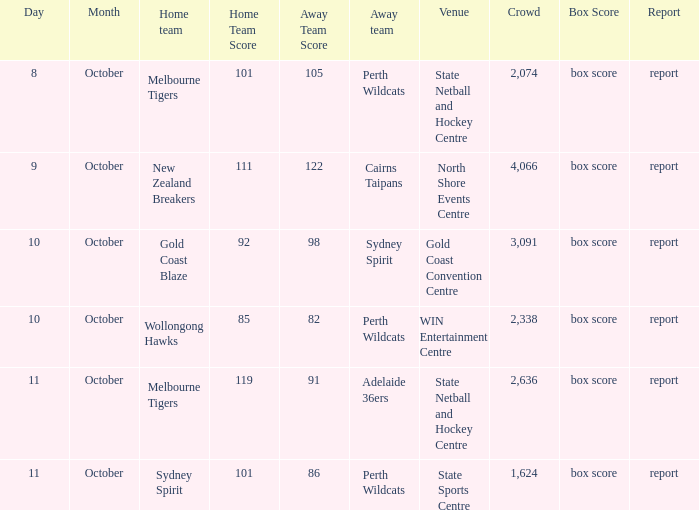What was the average crowd size for the game when the Gold Coast Blaze was the home team? 3091.0. 